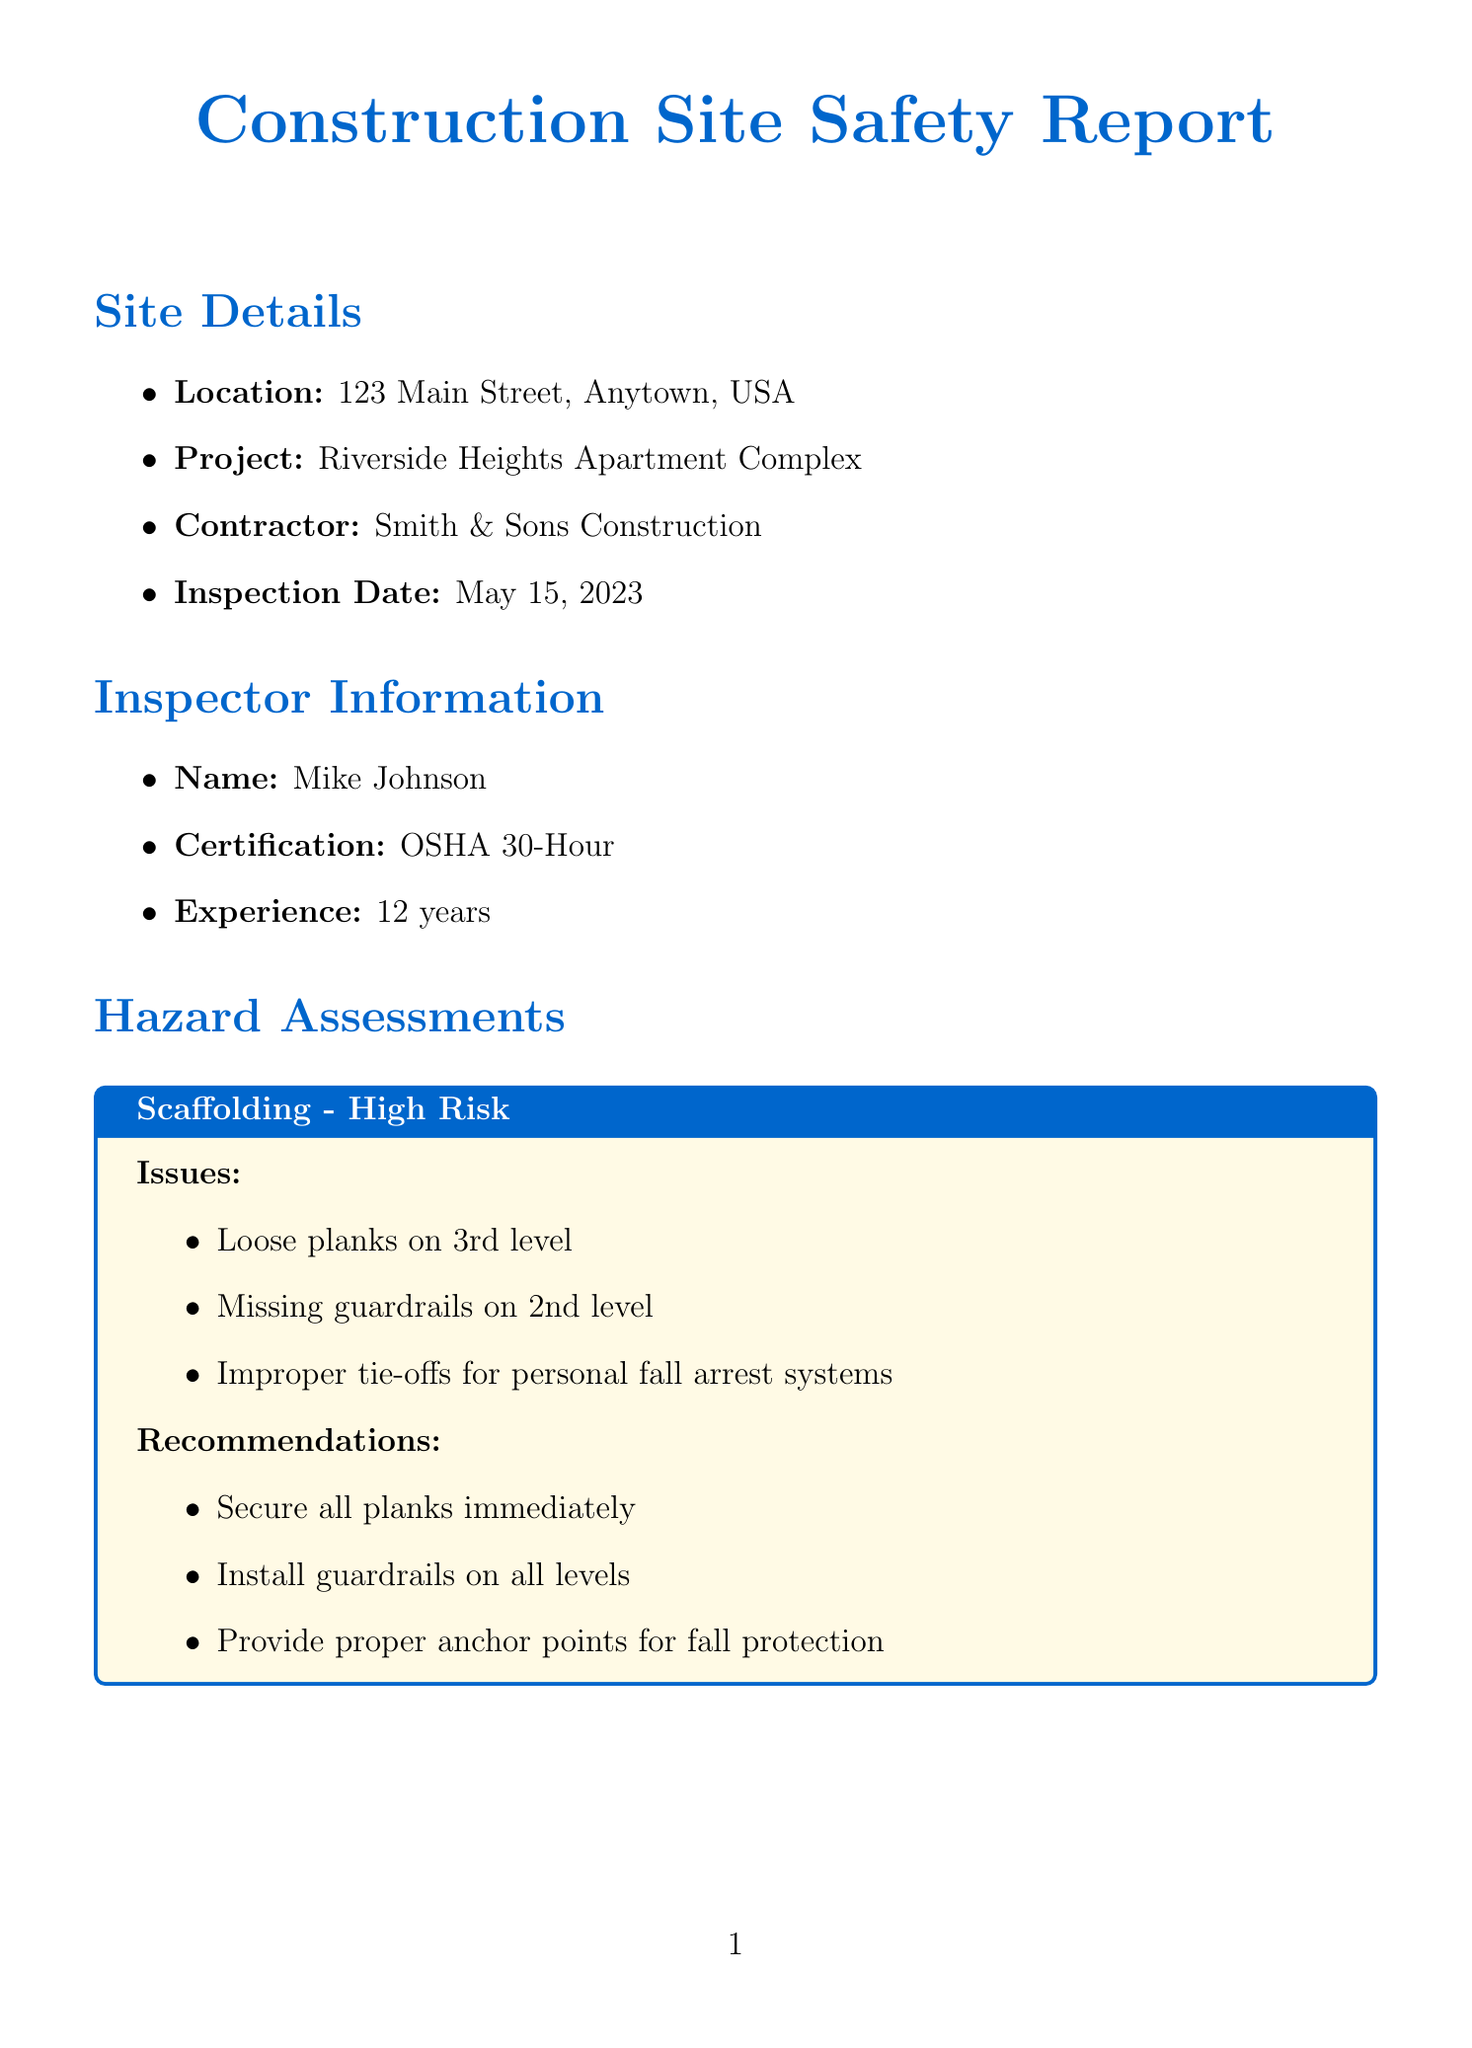What is the location of the construction site? The location is specified in the site details section of the document as "123 Main Street, Anytown, USA."
Answer: 123 Main Street, Anytown, USA Who conducted the inspection? The inspector's name is listed in the inspector information section as Mike Johnson.
Answer: Mike Johnson What is the overall safety rating? The overall safety rating is noted at the conclusion of the document.
Answer: 6/10 What percentage of compliance is there for safety glasses? The PPE compliance section provides the percentage of compliance for safety glasses as 75%.
Answer: 75% compliance What is one of the primary concerns listed in the conclusion? The conclusion lists the primary concerns, which include fall protection as one of them.
Answer: Fall protection What immediate action is required for scaffolding? The document specifies in the immediate actions required section that work on scaffolding should be stopped until guardrails are installed.
Answer: Stop work on scaffolding until guardrails are installed How many years of experience does the inspector have? The inspector's years of experience is mentioned in the inspector information section as 12 years.
Answer: 12 years What is one recommendation from the heavy machinery hazard assessment? Recommendations for heavy machinery include ensuring all operators are properly certified, as detailed in the hazard assessments section.
Answer: Ensure all operators are properly certified What is the fire safety condition on the site? The site conditions section describes the fire safety as acceptable, noting that extinguishers are present.
Answer: Acceptable 